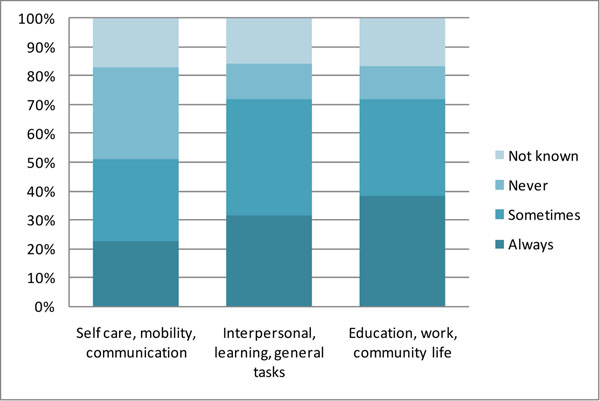extract information of this chart This chart shows the percentage of people who use assistive technology in different areas of their lives. The areas are self-care, mobility, communication, interpersonal, learning, general tasks, education, work, and community life.

The chart shows that the highest percentage of people use assistive technology for self-care, followed by mobility and communication. The lowest percentage of people use assistive technology for education, work, and community life.

The chart also shows that a significant number of people use assistive technology in multiple areas of their lives. For example, over 50% of people who use assistive technology for self-care also use it for mobility. 